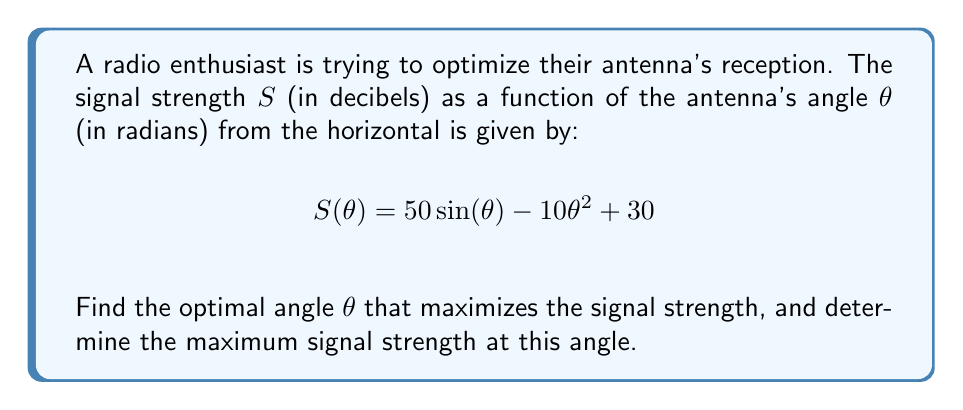Give your solution to this math problem. To find the optimal angle that maximizes the signal strength, we need to use calculus optimization techniques. Here's a step-by-step approach:

1. Find the derivative of $S(\theta)$ with respect to $\theta$:
   $$S'(\theta) = 50 \cos(\theta) - 20\theta$$

2. Set the derivative equal to zero to find critical points:
   $$50 \cos(\theta) - 20\theta = 0$$

3. Rearrange the equation:
   $$\cos(\theta) = \frac{2\theta}{5}$$

4. This equation cannot be solved algebraically. We need to use numerical methods or graphical approaches to find the solution. Using a graphing calculator or computer software, we can find that the solution is approximately:
   $$\theta \approx 0.8861 \text{ radians}$$

5. To confirm this is a maximum, we can check the second derivative:
   $$S''(\theta) = -50 \sin(\theta) - 20$$
   At $\theta \approx 0.8861$, $S''(\theta)$ is negative, confirming a local maximum.

6. Calculate the maximum signal strength by plugging the optimal angle back into the original function:
   $$S(0.8861) = 50 \sin(0.8861) - 10(0.8861)^2 + 30 \approx 60.6425 \text{ dB}$$
Answer: The optimal angle for maximum signal strength is approximately 0.8861 radians (about 50.8 degrees), and the maximum signal strength at this angle is approximately 60.6425 decibels. 